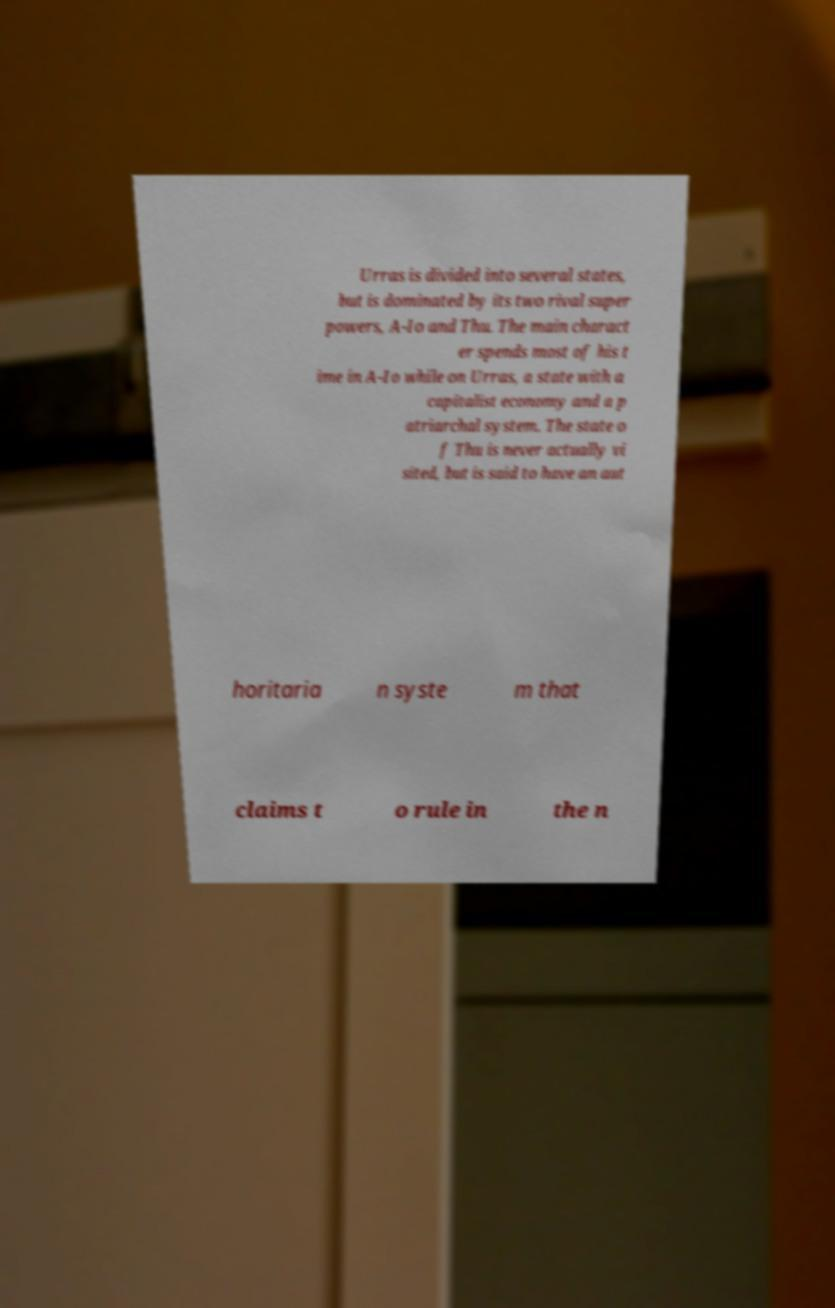Please identify and transcribe the text found in this image. Urras is divided into several states, but is dominated by its two rival super powers, A-Io and Thu. The main charact er spends most of his t ime in A-Io while on Urras, a state with a capitalist economy and a p atriarchal system. The state o f Thu is never actually vi sited, but is said to have an aut horitaria n syste m that claims t o rule in the n 